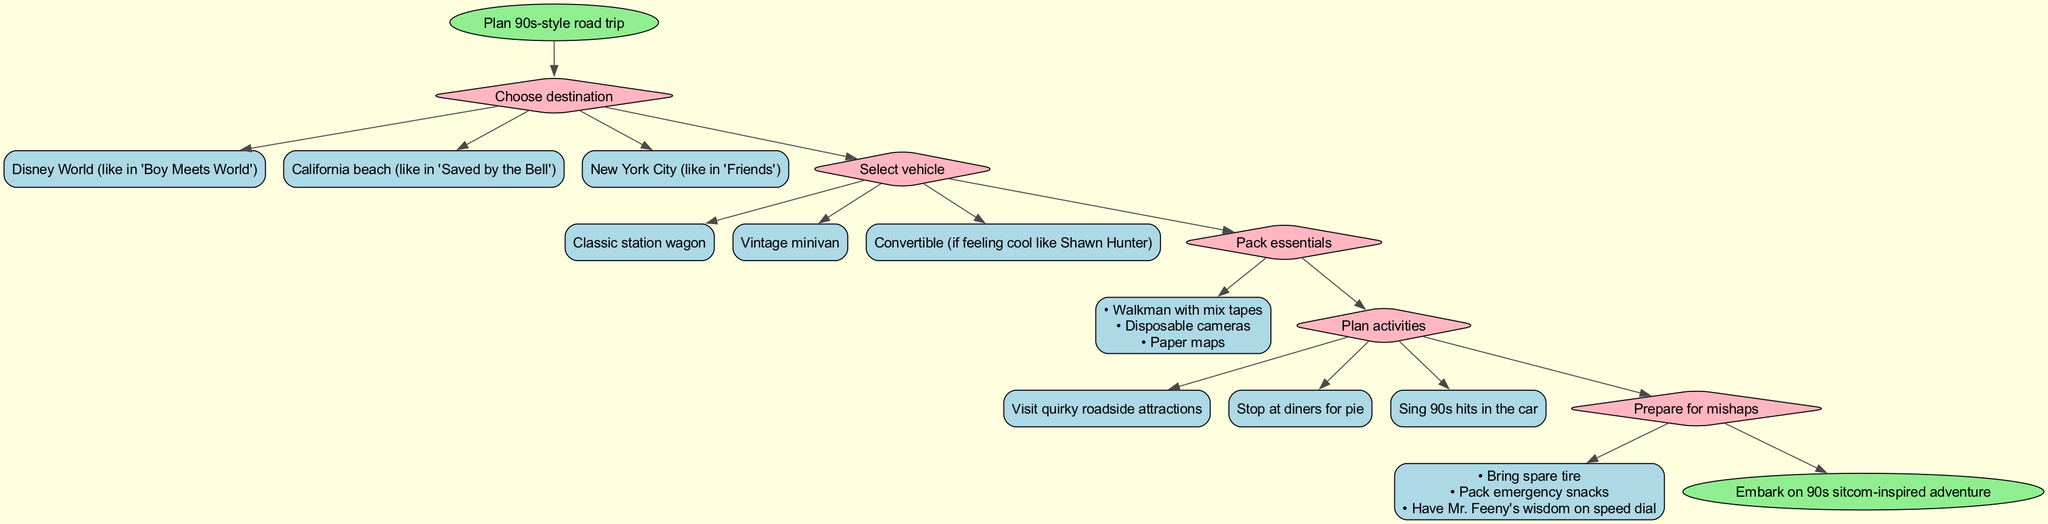What is the first step in the diagram? The first step is to choose a destination, which is indicated at the start of the flow chart.
Answer: Choose destination How many total steps are there in the diagram? There are five steps listed in the diagram, including the starting point and the ending point.
Answer: 5 What options are provided for selecting a vehicle? The options for selecting a vehicle can be found in the step that specifically deals with vehicle selection and includes three choices.
Answer: Classic station wagon, Vintage minivan, Convertible What items are recommended to pack? The items to pack are listed under the packing essentials step, which specifies three particular items to bring along.
Answer: Walkman with mix tapes, Disposable cameras, Paper maps What is the last action before ending the diagram? The last action is to embark on the road trip adventure, and it follows the preparation steps for mishaps.
Answer: Embark on 90s sitcom-inspired adventure How many options are available for planning activities? The planning activities step offers three specific options for activities during the road trip, each aimed at embracing the nostalgic spirit of 90s sitcoms.
Answer: 3 What is one mishap preparation item mentioned in the diagram? The diagram lists several items prepared for mishaps, and one of them is to bring emergency snacks.
Answer: Emergency snacks Which destination option is inspired by “Boy Meets World”? The destination inspired by “Boy Meets World” is specifically one of the three options provided at the start of the diagram.
Answer: Disney World Which vehicle option is described with a cool reference? The vehicle option that includes a cool reference is related to one of the characters from “Boy Meets World,” particularly focusing on a convertible.
Answer: Convertible (if feeling cool like Shawn Hunter) What relationships exist between the steps in the diagram? The diagram visually represents the flow from one node to the next, showing directional edges from the start to each subsequent step before arriving at the end node.
Answer: Sequential flow from start to end 